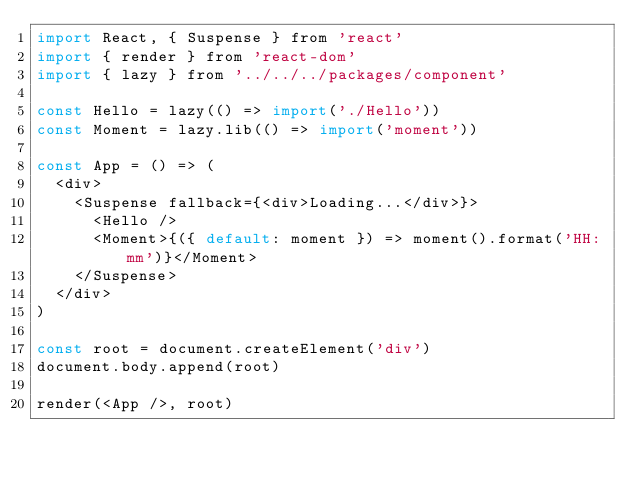<code> <loc_0><loc_0><loc_500><loc_500><_JavaScript_>import React, { Suspense } from 'react'
import { render } from 'react-dom'
import { lazy } from '../../../packages/component'

const Hello = lazy(() => import('./Hello'))
const Moment = lazy.lib(() => import('moment'))

const App = () => (
  <div>
    <Suspense fallback={<div>Loading...</div>}>
      <Hello />
      <Moment>{({ default: moment }) => moment().format('HH:mm')}</Moment>
    </Suspense>
  </div>
)

const root = document.createElement('div')
document.body.append(root)

render(<App />, root)
</code> 